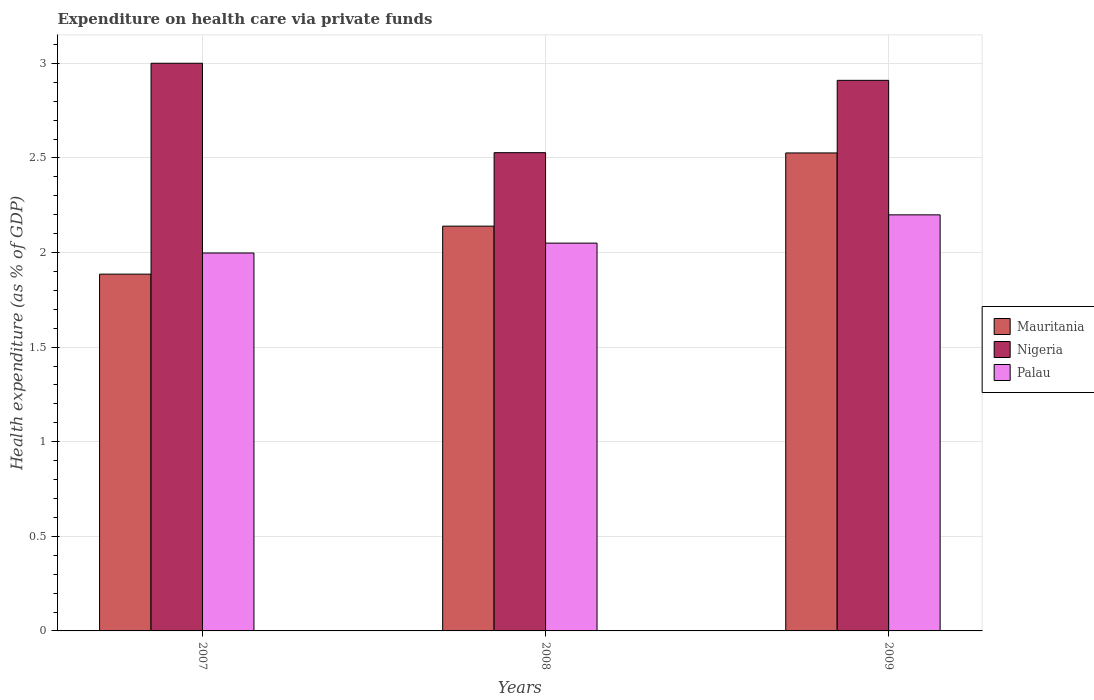How many groups of bars are there?
Give a very brief answer. 3. Are the number of bars per tick equal to the number of legend labels?
Make the answer very short. Yes. Are the number of bars on each tick of the X-axis equal?
Your answer should be very brief. Yes. What is the label of the 3rd group of bars from the left?
Offer a very short reply. 2009. What is the expenditure made on health care in Mauritania in 2008?
Give a very brief answer. 2.14. Across all years, what is the maximum expenditure made on health care in Mauritania?
Make the answer very short. 2.53. Across all years, what is the minimum expenditure made on health care in Palau?
Offer a terse response. 2. In which year was the expenditure made on health care in Palau maximum?
Offer a very short reply. 2009. What is the total expenditure made on health care in Palau in the graph?
Make the answer very short. 6.25. What is the difference between the expenditure made on health care in Palau in 2007 and that in 2009?
Keep it short and to the point. -0.2. What is the difference between the expenditure made on health care in Nigeria in 2007 and the expenditure made on health care in Palau in 2008?
Offer a terse response. 0.95. What is the average expenditure made on health care in Mauritania per year?
Keep it short and to the point. 2.18. In the year 2008, what is the difference between the expenditure made on health care in Nigeria and expenditure made on health care in Palau?
Ensure brevity in your answer.  0.48. In how many years, is the expenditure made on health care in Nigeria greater than 1.7 %?
Ensure brevity in your answer.  3. What is the ratio of the expenditure made on health care in Nigeria in 2007 to that in 2009?
Your answer should be very brief. 1.03. Is the expenditure made on health care in Mauritania in 2007 less than that in 2008?
Provide a short and direct response. Yes. Is the difference between the expenditure made on health care in Nigeria in 2007 and 2008 greater than the difference between the expenditure made on health care in Palau in 2007 and 2008?
Your response must be concise. Yes. What is the difference between the highest and the second highest expenditure made on health care in Nigeria?
Make the answer very short. 0.09. What is the difference between the highest and the lowest expenditure made on health care in Mauritania?
Offer a terse response. 0.64. Is the sum of the expenditure made on health care in Nigeria in 2008 and 2009 greater than the maximum expenditure made on health care in Palau across all years?
Give a very brief answer. Yes. What does the 1st bar from the left in 2008 represents?
Your answer should be compact. Mauritania. What does the 2nd bar from the right in 2007 represents?
Offer a very short reply. Nigeria. Is it the case that in every year, the sum of the expenditure made on health care in Palau and expenditure made on health care in Mauritania is greater than the expenditure made on health care in Nigeria?
Ensure brevity in your answer.  Yes. Are all the bars in the graph horizontal?
Provide a succinct answer. No. How many years are there in the graph?
Offer a very short reply. 3. What is the difference between two consecutive major ticks on the Y-axis?
Make the answer very short. 0.5. Are the values on the major ticks of Y-axis written in scientific E-notation?
Your response must be concise. No. Does the graph contain any zero values?
Offer a very short reply. No. Where does the legend appear in the graph?
Keep it short and to the point. Center right. How many legend labels are there?
Your response must be concise. 3. How are the legend labels stacked?
Make the answer very short. Vertical. What is the title of the graph?
Make the answer very short. Expenditure on health care via private funds. Does "World" appear as one of the legend labels in the graph?
Offer a very short reply. No. What is the label or title of the X-axis?
Provide a succinct answer. Years. What is the label or title of the Y-axis?
Give a very brief answer. Health expenditure (as % of GDP). What is the Health expenditure (as % of GDP) of Mauritania in 2007?
Give a very brief answer. 1.89. What is the Health expenditure (as % of GDP) of Nigeria in 2007?
Offer a very short reply. 3. What is the Health expenditure (as % of GDP) of Palau in 2007?
Your answer should be very brief. 2. What is the Health expenditure (as % of GDP) in Mauritania in 2008?
Your answer should be very brief. 2.14. What is the Health expenditure (as % of GDP) of Nigeria in 2008?
Offer a terse response. 2.53. What is the Health expenditure (as % of GDP) in Palau in 2008?
Make the answer very short. 2.05. What is the Health expenditure (as % of GDP) of Mauritania in 2009?
Offer a terse response. 2.53. What is the Health expenditure (as % of GDP) of Nigeria in 2009?
Keep it short and to the point. 2.91. What is the Health expenditure (as % of GDP) in Palau in 2009?
Your answer should be very brief. 2.2. Across all years, what is the maximum Health expenditure (as % of GDP) of Mauritania?
Give a very brief answer. 2.53. Across all years, what is the maximum Health expenditure (as % of GDP) in Nigeria?
Ensure brevity in your answer.  3. Across all years, what is the maximum Health expenditure (as % of GDP) of Palau?
Offer a very short reply. 2.2. Across all years, what is the minimum Health expenditure (as % of GDP) of Mauritania?
Make the answer very short. 1.89. Across all years, what is the minimum Health expenditure (as % of GDP) of Nigeria?
Offer a very short reply. 2.53. Across all years, what is the minimum Health expenditure (as % of GDP) of Palau?
Offer a terse response. 2. What is the total Health expenditure (as % of GDP) of Mauritania in the graph?
Ensure brevity in your answer.  6.55. What is the total Health expenditure (as % of GDP) in Nigeria in the graph?
Provide a succinct answer. 8.44. What is the total Health expenditure (as % of GDP) in Palau in the graph?
Make the answer very short. 6.25. What is the difference between the Health expenditure (as % of GDP) of Mauritania in 2007 and that in 2008?
Your answer should be compact. -0.25. What is the difference between the Health expenditure (as % of GDP) in Nigeria in 2007 and that in 2008?
Provide a succinct answer. 0.47. What is the difference between the Health expenditure (as % of GDP) of Palau in 2007 and that in 2008?
Ensure brevity in your answer.  -0.05. What is the difference between the Health expenditure (as % of GDP) in Mauritania in 2007 and that in 2009?
Your answer should be compact. -0.64. What is the difference between the Health expenditure (as % of GDP) of Nigeria in 2007 and that in 2009?
Provide a short and direct response. 0.09. What is the difference between the Health expenditure (as % of GDP) in Palau in 2007 and that in 2009?
Keep it short and to the point. -0.2. What is the difference between the Health expenditure (as % of GDP) in Mauritania in 2008 and that in 2009?
Your answer should be compact. -0.39. What is the difference between the Health expenditure (as % of GDP) of Nigeria in 2008 and that in 2009?
Offer a very short reply. -0.38. What is the difference between the Health expenditure (as % of GDP) in Palau in 2008 and that in 2009?
Offer a terse response. -0.15. What is the difference between the Health expenditure (as % of GDP) in Mauritania in 2007 and the Health expenditure (as % of GDP) in Nigeria in 2008?
Offer a terse response. -0.64. What is the difference between the Health expenditure (as % of GDP) in Mauritania in 2007 and the Health expenditure (as % of GDP) in Palau in 2008?
Keep it short and to the point. -0.16. What is the difference between the Health expenditure (as % of GDP) of Nigeria in 2007 and the Health expenditure (as % of GDP) of Palau in 2008?
Give a very brief answer. 0.95. What is the difference between the Health expenditure (as % of GDP) of Mauritania in 2007 and the Health expenditure (as % of GDP) of Nigeria in 2009?
Provide a short and direct response. -1.02. What is the difference between the Health expenditure (as % of GDP) of Mauritania in 2007 and the Health expenditure (as % of GDP) of Palau in 2009?
Your response must be concise. -0.31. What is the difference between the Health expenditure (as % of GDP) of Nigeria in 2007 and the Health expenditure (as % of GDP) of Palau in 2009?
Provide a short and direct response. 0.8. What is the difference between the Health expenditure (as % of GDP) in Mauritania in 2008 and the Health expenditure (as % of GDP) in Nigeria in 2009?
Keep it short and to the point. -0.77. What is the difference between the Health expenditure (as % of GDP) of Mauritania in 2008 and the Health expenditure (as % of GDP) of Palau in 2009?
Your answer should be very brief. -0.06. What is the difference between the Health expenditure (as % of GDP) in Nigeria in 2008 and the Health expenditure (as % of GDP) in Palau in 2009?
Provide a short and direct response. 0.33. What is the average Health expenditure (as % of GDP) in Mauritania per year?
Your response must be concise. 2.18. What is the average Health expenditure (as % of GDP) of Nigeria per year?
Offer a terse response. 2.81. What is the average Health expenditure (as % of GDP) in Palau per year?
Your answer should be very brief. 2.08. In the year 2007, what is the difference between the Health expenditure (as % of GDP) in Mauritania and Health expenditure (as % of GDP) in Nigeria?
Your response must be concise. -1.11. In the year 2007, what is the difference between the Health expenditure (as % of GDP) of Mauritania and Health expenditure (as % of GDP) of Palau?
Give a very brief answer. -0.11. In the year 2008, what is the difference between the Health expenditure (as % of GDP) of Mauritania and Health expenditure (as % of GDP) of Nigeria?
Provide a succinct answer. -0.39. In the year 2008, what is the difference between the Health expenditure (as % of GDP) of Mauritania and Health expenditure (as % of GDP) of Palau?
Provide a succinct answer. 0.09. In the year 2008, what is the difference between the Health expenditure (as % of GDP) in Nigeria and Health expenditure (as % of GDP) in Palau?
Provide a short and direct response. 0.48. In the year 2009, what is the difference between the Health expenditure (as % of GDP) in Mauritania and Health expenditure (as % of GDP) in Nigeria?
Offer a very short reply. -0.38. In the year 2009, what is the difference between the Health expenditure (as % of GDP) of Mauritania and Health expenditure (as % of GDP) of Palau?
Ensure brevity in your answer.  0.33. In the year 2009, what is the difference between the Health expenditure (as % of GDP) in Nigeria and Health expenditure (as % of GDP) in Palau?
Keep it short and to the point. 0.71. What is the ratio of the Health expenditure (as % of GDP) in Mauritania in 2007 to that in 2008?
Give a very brief answer. 0.88. What is the ratio of the Health expenditure (as % of GDP) in Nigeria in 2007 to that in 2008?
Offer a terse response. 1.19. What is the ratio of the Health expenditure (as % of GDP) of Palau in 2007 to that in 2008?
Keep it short and to the point. 0.97. What is the ratio of the Health expenditure (as % of GDP) of Mauritania in 2007 to that in 2009?
Make the answer very short. 0.75. What is the ratio of the Health expenditure (as % of GDP) in Nigeria in 2007 to that in 2009?
Keep it short and to the point. 1.03. What is the ratio of the Health expenditure (as % of GDP) in Palau in 2007 to that in 2009?
Keep it short and to the point. 0.91. What is the ratio of the Health expenditure (as % of GDP) in Mauritania in 2008 to that in 2009?
Give a very brief answer. 0.85. What is the ratio of the Health expenditure (as % of GDP) in Nigeria in 2008 to that in 2009?
Make the answer very short. 0.87. What is the ratio of the Health expenditure (as % of GDP) in Palau in 2008 to that in 2009?
Your answer should be compact. 0.93. What is the difference between the highest and the second highest Health expenditure (as % of GDP) in Mauritania?
Offer a terse response. 0.39. What is the difference between the highest and the second highest Health expenditure (as % of GDP) of Nigeria?
Offer a very short reply. 0.09. What is the difference between the highest and the second highest Health expenditure (as % of GDP) in Palau?
Ensure brevity in your answer.  0.15. What is the difference between the highest and the lowest Health expenditure (as % of GDP) of Mauritania?
Give a very brief answer. 0.64. What is the difference between the highest and the lowest Health expenditure (as % of GDP) in Nigeria?
Your answer should be compact. 0.47. What is the difference between the highest and the lowest Health expenditure (as % of GDP) of Palau?
Your response must be concise. 0.2. 